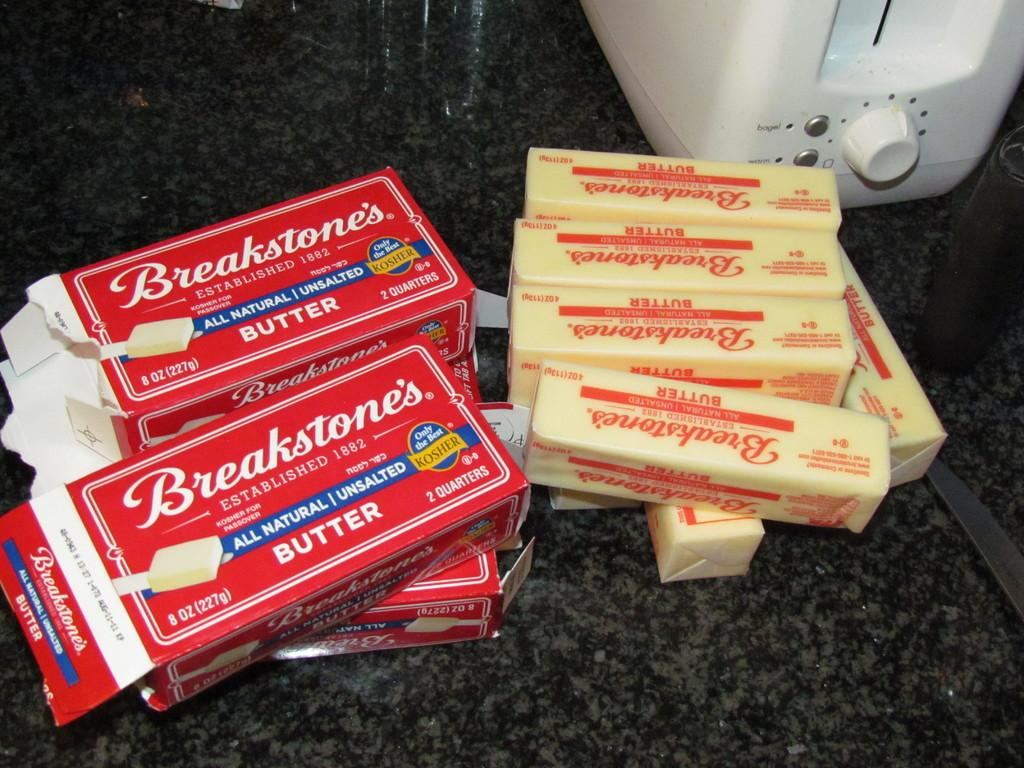<image>
Summarize the visual content of the image. The contents of several Breakstone Butter boxes lie on a counter. 